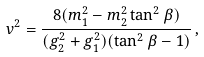<formula> <loc_0><loc_0><loc_500><loc_500>v ^ { 2 } = \frac { 8 ( m ^ { 2 } _ { 1 } - m ^ { 2 } _ { 2 } \tan ^ { 2 } { \beta } ) } { ( g ^ { 2 } _ { 2 } + { g } ^ { 2 } _ { 1 } ) ( \tan ^ { 2 } { \beta } - 1 ) } \, ,</formula> 